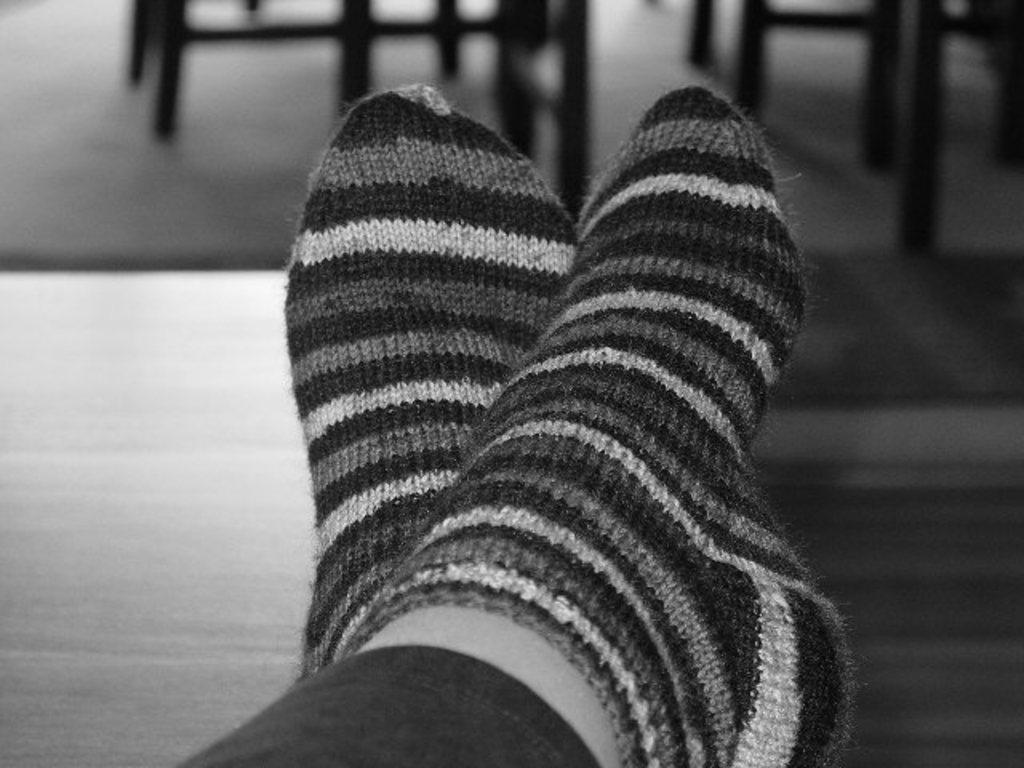What is the color scheme of the image? The image is black and white. What part of a person's body can be seen in the image? There are feet with socks visible in the image. Can you describe the background of the image? The background of the image is blurred. What type of invention is being demonstrated by the band in the image? There is no band or invention present in the image; it only features a person's feet with socks. What type of cord is connected to the person's feet in the image? There is no cord connected to the person's feet in the image; only socks are visible. 